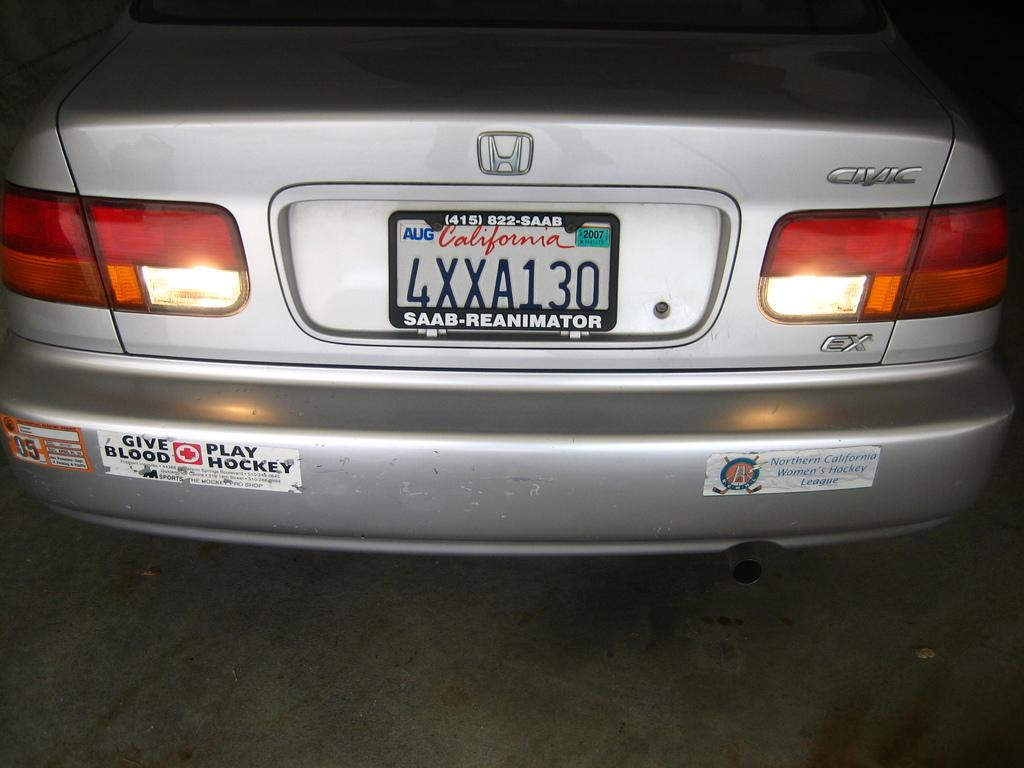<image>
Give a short and clear explanation of the subsequent image. a license plate that has the word California on it 